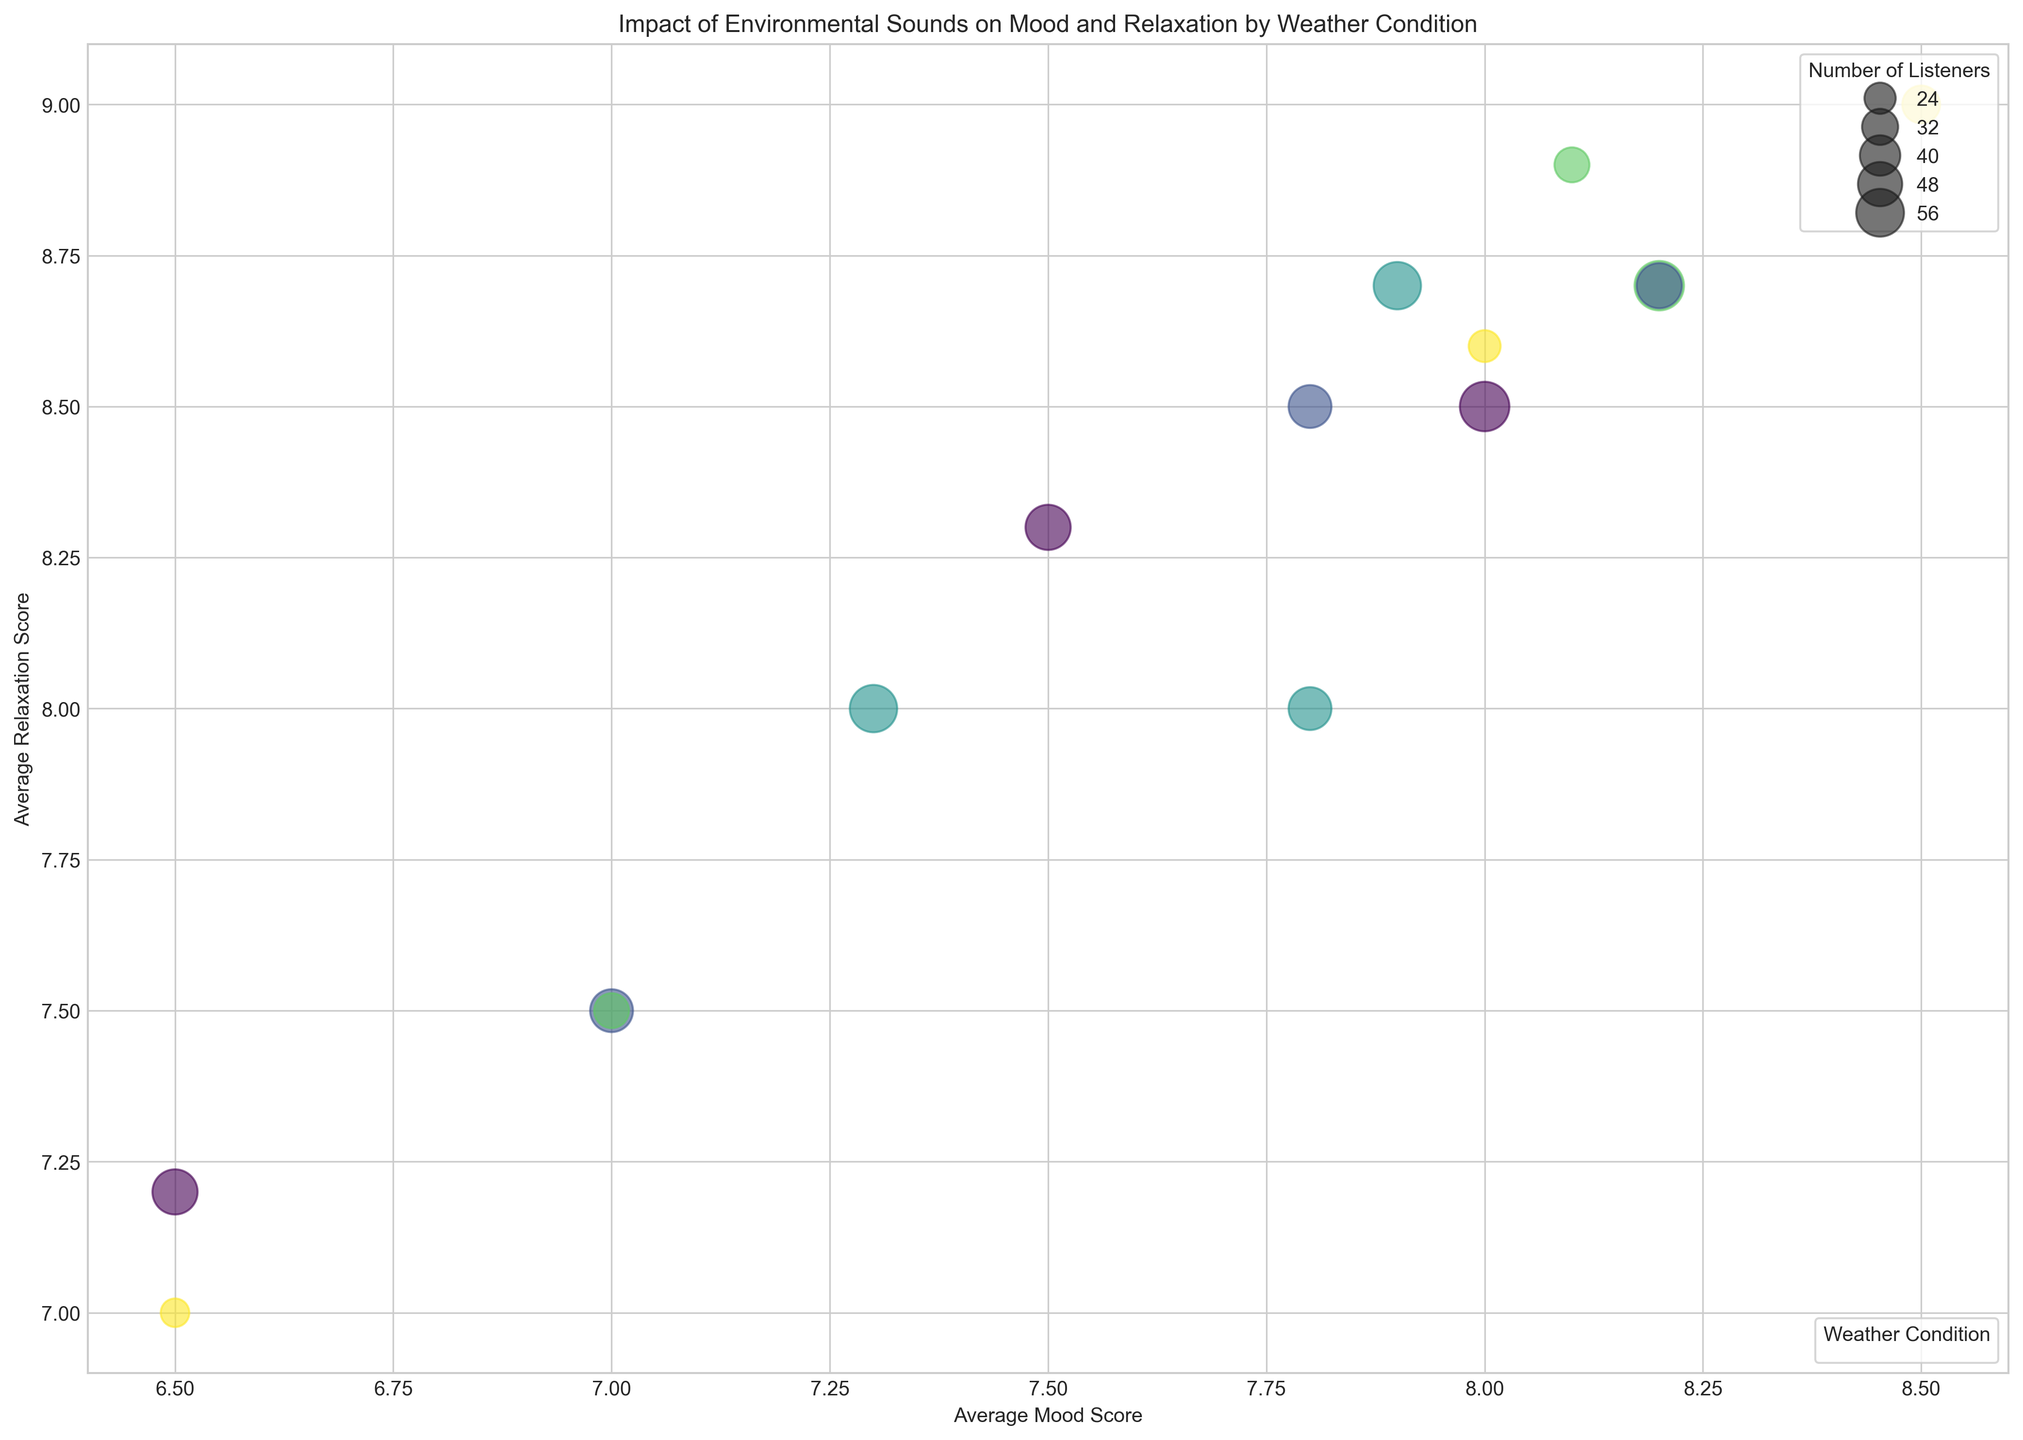What is the weather condition that leads to the highest average mood score for Rain sound? By looking at the data points for Rain sound, the highest average mood score occurs under Stormy weather with a score of 8.5.
Answer: Stormy How many listeners experienced Ocean Waves under Partly Cloudy weather? The data point for Ocean Waves with Partly Cloudy weather shows a number of listeners equal to 45.
Answer: 45 Which environmental sound has the highest relaxation scores in a Sunny condition? In Sunny weather, the relaxation scores for Rain, Ocean Waves, and Birds are 7.2, 8.3, and 8.5 respectively. Birds have the highest relaxation score.
Answer: Birds Compare the average mood scores of Birds and Rain in Cloudy conditions. Which is higher? Under Cloudy conditions, Birds have an average mood score of 7.8 and Rain has an average mood score of 7.3. Birds have the higher score.
Answer: Birds What is the color used to represent Partly Cloudy weather condition? The weather conditions are color-coded; by referring to the legend elements, we can identify the specific color for Partly Cloudy. It appears as a certain shade determined on the color map, which should be detailed in the chart.
Answer: (color in the figure) For Rainy weather, which environmental sound has the highest relaxation score? By comparing the relaxation scores in Rainy weather, Ocean Waves have a score of 8.9, Rain has 8.7, and Birds have 7.5. Ocean Waves have the highest relaxation score.
Answer: Ocean Waves What is the difference in average mood score between Rain and Birds under Stormy conditions? Rain has an average mood score of 8.5 and Birds have 6.5 under Stormy conditions. The difference is 8.5 - 6.5 = 2.0.
Answer: 2.0 Which environmental sound attracts the most listeners in a Sunny condition? Looking at the number of listeners in Sunny conditions: Rain has 50, Ocean Waves have 50, and Birds have 60. Birds attract the most listeners.
Answer: Birds What is the correlation between the number of listeners and the relaxation score for Birds in Partly Cloudy conditions? For visual correlation, the data shows Birds in Partly Cloudy conditions had a relaxation score of 8.7 and 50 listeners. Evaluating the overall trend in the data can reveal correlations.
Answer: (interpret from figure trends) 